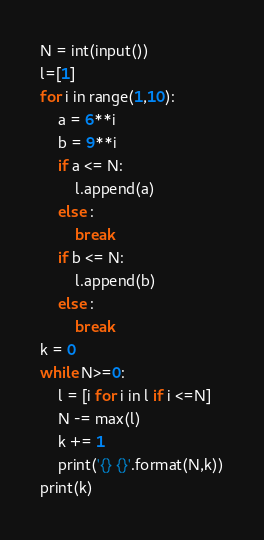<code> <loc_0><loc_0><loc_500><loc_500><_Python_>N = int(input())
l=[1]
for i in range(1,10):
    a = 6**i
    b = 9**i
    if a <= N:
        l.append(a)
    else :
        break
    if b <= N:
        l.append(b)
    else :
        break
k = 0
while N>=0:
    l = [i for i in l if i <=N]
    N -= max(l)
    k += 1
    print('{} {}'.format(N,k))
print(k)
</code> 